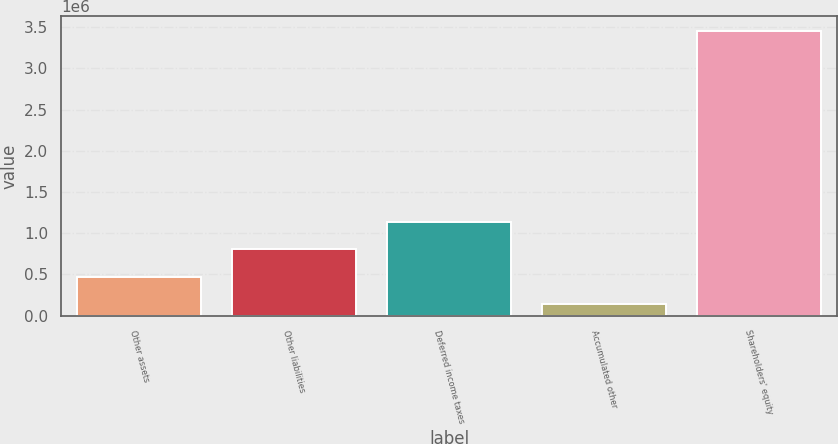Convert chart. <chart><loc_0><loc_0><loc_500><loc_500><bar_chart><fcel>Other assets<fcel>Other liabilities<fcel>Deferred income taxes<fcel>Accumulated other<fcel>Shareholders' equity<nl><fcel>472007<fcel>803916<fcel>1.13583e+06<fcel>140097<fcel>3.45919e+06<nl></chart> 